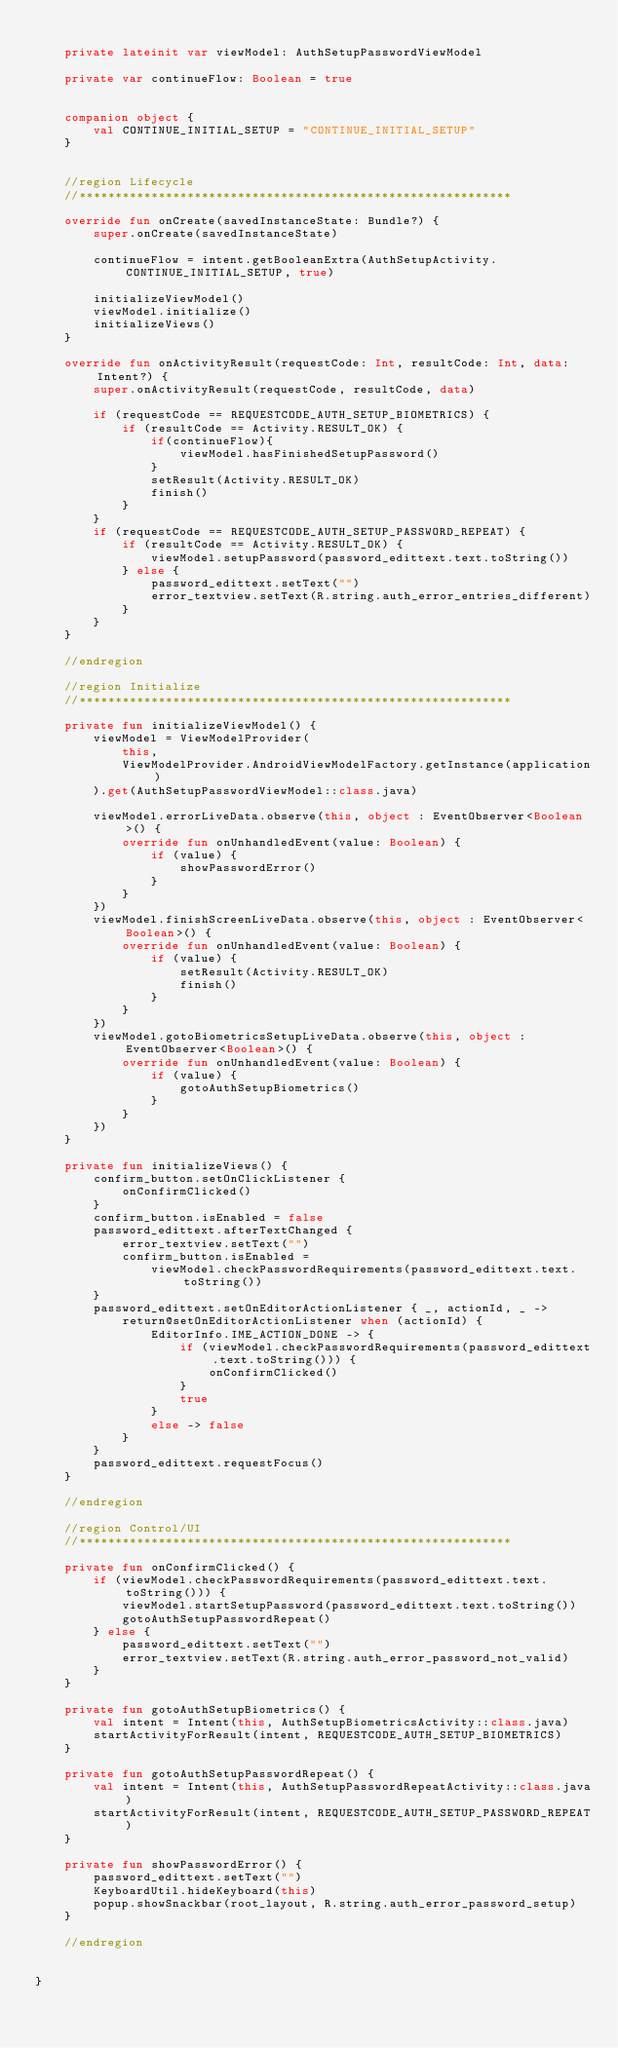<code> <loc_0><loc_0><loc_500><loc_500><_Kotlin_>
    private lateinit var viewModel: AuthSetupPasswordViewModel

    private var continueFlow: Boolean = true


    companion object {
        val CONTINUE_INITIAL_SETUP = "CONTINUE_INITIAL_SETUP"
    }


    //region Lifecycle
    //************************************************************

    override fun onCreate(savedInstanceState: Bundle?) {
        super.onCreate(savedInstanceState)

        continueFlow = intent.getBooleanExtra(AuthSetupActivity.CONTINUE_INITIAL_SETUP, true)

        initializeViewModel()
        viewModel.initialize()
        initializeViews()
    }

    override fun onActivityResult(requestCode: Int, resultCode: Int, data: Intent?) {
        super.onActivityResult(requestCode, resultCode, data)

        if (requestCode == REQUESTCODE_AUTH_SETUP_BIOMETRICS) {
            if (resultCode == Activity.RESULT_OK) {
                if(continueFlow){
                    viewModel.hasFinishedSetupPassword()
                }
                setResult(Activity.RESULT_OK)
                finish()
            }
        }
        if (requestCode == REQUESTCODE_AUTH_SETUP_PASSWORD_REPEAT) {
            if (resultCode == Activity.RESULT_OK) {
                viewModel.setupPassword(password_edittext.text.toString())
            } else {
                password_edittext.setText("")
                error_textview.setText(R.string.auth_error_entries_different)
            }
        }
    }

    //endregion

    //region Initialize
    //************************************************************

    private fun initializeViewModel() {
        viewModel = ViewModelProvider(
            this,
            ViewModelProvider.AndroidViewModelFactory.getInstance(application)
        ).get(AuthSetupPasswordViewModel::class.java)

        viewModel.errorLiveData.observe(this, object : EventObserver<Boolean>() {
            override fun onUnhandledEvent(value: Boolean) {
                if (value) {
                    showPasswordError()
                }
            }
        })
        viewModel.finishScreenLiveData.observe(this, object : EventObserver<Boolean>() {
            override fun onUnhandledEvent(value: Boolean) {
                if (value) {
                    setResult(Activity.RESULT_OK)
                    finish()
                }
            }
        })
        viewModel.gotoBiometricsSetupLiveData.observe(this, object : EventObserver<Boolean>() {
            override fun onUnhandledEvent(value: Boolean) {
                if (value) {
                    gotoAuthSetupBiometrics()
                }
            }
        })
    }

    private fun initializeViews() {
        confirm_button.setOnClickListener {
            onConfirmClicked()
        }
        confirm_button.isEnabled = false
        password_edittext.afterTextChanged {
            error_textview.setText("")
            confirm_button.isEnabled =
                viewModel.checkPasswordRequirements(password_edittext.text.toString())
        }
        password_edittext.setOnEditorActionListener { _, actionId, _ ->
            return@setOnEditorActionListener when (actionId) {
                EditorInfo.IME_ACTION_DONE -> {
                    if (viewModel.checkPasswordRequirements(password_edittext.text.toString())) {
                        onConfirmClicked()
                    }
                    true
                }
                else -> false
            }
        }
        password_edittext.requestFocus()
    }

    //endregion

    //region Control/UI
    //************************************************************

    private fun onConfirmClicked() {
        if (viewModel.checkPasswordRequirements(password_edittext.text.toString())) {
            viewModel.startSetupPassword(password_edittext.text.toString())
            gotoAuthSetupPasswordRepeat()
        } else {
            password_edittext.setText("")
            error_textview.setText(R.string.auth_error_password_not_valid)
        }
    }

    private fun gotoAuthSetupBiometrics() {
        val intent = Intent(this, AuthSetupBiometricsActivity::class.java)
        startActivityForResult(intent, REQUESTCODE_AUTH_SETUP_BIOMETRICS)
    }

    private fun gotoAuthSetupPasswordRepeat() {
        val intent = Intent(this, AuthSetupPasswordRepeatActivity::class.java)
        startActivityForResult(intent, REQUESTCODE_AUTH_SETUP_PASSWORD_REPEAT)
    }

    private fun showPasswordError() {
        password_edittext.setText("")
        KeyboardUtil.hideKeyboard(this)
        popup.showSnackbar(root_layout, R.string.auth_error_password_setup)
    }

    //endregion


}
</code> 